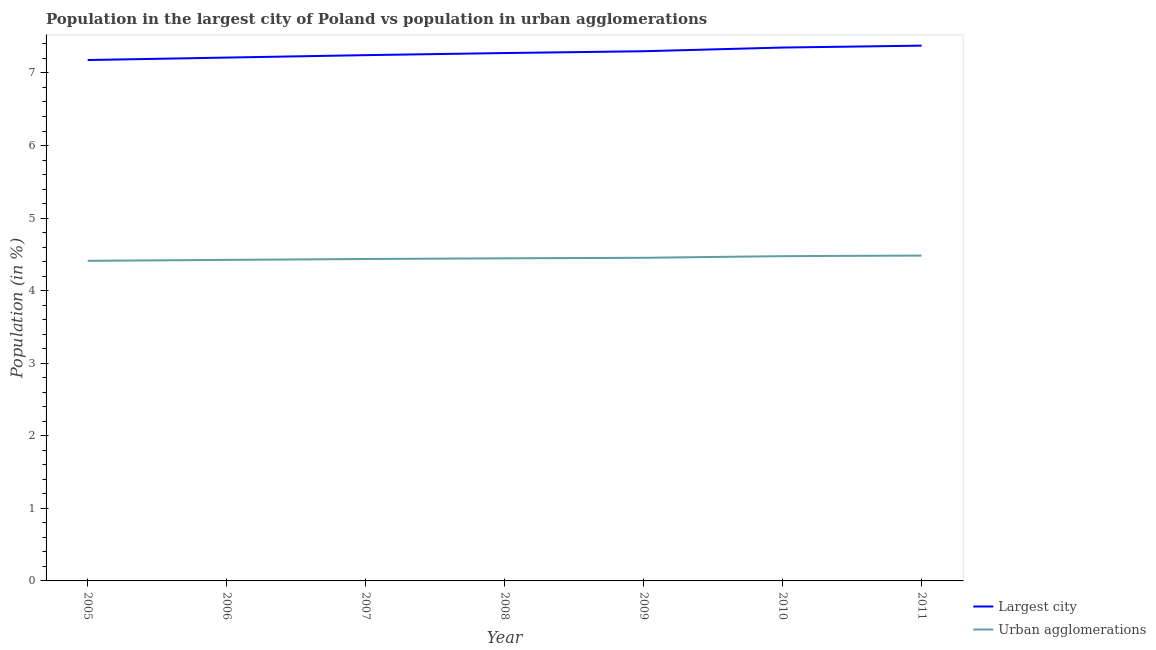What is the population in the largest city in 2009?
Provide a short and direct response. 7.3. Across all years, what is the maximum population in urban agglomerations?
Ensure brevity in your answer.  4.48. Across all years, what is the minimum population in the largest city?
Offer a terse response. 7.18. What is the total population in the largest city in the graph?
Provide a short and direct response. 50.94. What is the difference between the population in the largest city in 2006 and that in 2009?
Provide a short and direct response. -0.09. What is the difference between the population in urban agglomerations in 2007 and the population in the largest city in 2005?
Ensure brevity in your answer.  -2.74. What is the average population in urban agglomerations per year?
Keep it short and to the point. 4.45. In the year 2009, what is the difference between the population in the largest city and population in urban agglomerations?
Your answer should be very brief. 2.85. In how many years, is the population in urban agglomerations greater than 5.6 %?
Provide a short and direct response. 0. What is the ratio of the population in the largest city in 2007 to that in 2009?
Offer a terse response. 0.99. What is the difference between the highest and the second highest population in the largest city?
Your answer should be very brief. 0.03. What is the difference between the highest and the lowest population in the largest city?
Provide a short and direct response. 0.2. In how many years, is the population in the largest city greater than the average population in the largest city taken over all years?
Give a very brief answer. 3. Is the sum of the population in the largest city in 2009 and 2011 greater than the maximum population in urban agglomerations across all years?
Provide a succinct answer. Yes. Does the population in urban agglomerations monotonically increase over the years?
Ensure brevity in your answer.  Yes. How many lines are there?
Offer a terse response. 2. How many years are there in the graph?
Ensure brevity in your answer.  7. Are the values on the major ticks of Y-axis written in scientific E-notation?
Offer a very short reply. No. Does the graph contain any zero values?
Ensure brevity in your answer.  No. Where does the legend appear in the graph?
Your response must be concise. Bottom right. How are the legend labels stacked?
Offer a terse response. Vertical. What is the title of the graph?
Provide a succinct answer. Population in the largest city of Poland vs population in urban agglomerations. What is the label or title of the X-axis?
Ensure brevity in your answer.  Year. What is the Population (in %) in Largest city in 2005?
Ensure brevity in your answer.  7.18. What is the Population (in %) in Urban agglomerations in 2005?
Ensure brevity in your answer.  4.41. What is the Population (in %) of Largest city in 2006?
Your response must be concise. 7.21. What is the Population (in %) of Urban agglomerations in 2006?
Your answer should be compact. 4.42. What is the Population (in %) of Largest city in 2007?
Your response must be concise. 7.25. What is the Population (in %) of Urban agglomerations in 2007?
Provide a short and direct response. 4.44. What is the Population (in %) of Largest city in 2008?
Your answer should be very brief. 7.27. What is the Population (in %) in Urban agglomerations in 2008?
Make the answer very short. 4.45. What is the Population (in %) of Largest city in 2009?
Offer a terse response. 7.3. What is the Population (in %) of Urban agglomerations in 2009?
Your answer should be compact. 4.45. What is the Population (in %) of Largest city in 2010?
Your response must be concise. 7.35. What is the Population (in %) in Urban agglomerations in 2010?
Offer a terse response. 4.48. What is the Population (in %) of Largest city in 2011?
Keep it short and to the point. 7.38. What is the Population (in %) of Urban agglomerations in 2011?
Provide a succinct answer. 4.48. Across all years, what is the maximum Population (in %) in Largest city?
Your answer should be compact. 7.38. Across all years, what is the maximum Population (in %) in Urban agglomerations?
Your answer should be very brief. 4.48. Across all years, what is the minimum Population (in %) in Largest city?
Give a very brief answer. 7.18. Across all years, what is the minimum Population (in %) in Urban agglomerations?
Make the answer very short. 4.41. What is the total Population (in %) of Largest city in the graph?
Offer a terse response. 50.94. What is the total Population (in %) of Urban agglomerations in the graph?
Keep it short and to the point. 31.13. What is the difference between the Population (in %) in Largest city in 2005 and that in 2006?
Ensure brevity in your answer.  -0.03. What is the difference between the Population (in %) of Urban agglomerations in 2005 and that in 2006?
Provide a succinct answer. -0.01. What is the difference between the Population (in %) of Largest city in 2005 and that in 2007?
Your answer should be compact. -0.07. What is the difference between the Population (in %) in Urban agglomerations in 2005 and that in 2007?
Ensure brevity in your answer.  -0.03. What is the difference between the Population (in %) in Largest city in 2005 and that in 2008?
Offer a terse response. -0.1. What is the difference between the Population (in %) of Urban agglomerations in 2005 and that in 2008?
Your answer should be compact. -0.03. What is the difference between the Population (in %) of Largest city in 2005 and that in 2009?
Give a very brief answer. -0.12. What is the difference between the Population (in %) in Urban agglomerations in 2005 and that in 2009?
Offer a terse response. -0.04. What is the difference between the Population (in %) of Largest city in 2005 and that in 2010?
Provide a short and direct response. -0.17. What is the difference between the Population (in %) of Urban agglomerations in 2005 and that in 2010?
Give a very brief answer. -0.06. What is the difference between the Population (in %) in Largest city in 2005 and that in 2011?
Offer a terse response. -0.2. What is the difference between the Population (in %) in Urban agglomerations in 2005 and that in 2011?
Your answer should be very brief. -0.07. What is the difference between the Population (in %) of Largest city in 2006 and that in 2007?
Your answer should be very brief. -0.03. What is the difference between the Population (in %) of Urban agglomerations in 2006 and that in 2007?
Offer a very short reply. -0.01. What is the difference between the Population (in %) in Largest city in 2006 and that in 2008?
Offer a terse response. -0.06. What is the difference between the Population (in %) of Urban agglomerations in 2006 and that in 2008?
Your answer should be compact. -0.02. What is the difference between the Population (in %) in Largest city in 2006 and that in 2009?
Offer a very short reply. -0.09. What is the difference between the Population (in %) in Urban agglomerations in 2006 and that in 2009?
Your response must be concise. -0.03. What is the difference between the Population (in %) in Largest city in 2006 and that in 2010?
Offer a very short reply. -0.14. What is the difference between the Population (in %) in Urban agglomerations in 2006 and that in 2010?
Provide a short and direct response. -0.05. What is the difference between the Population (in %) of Largest city in 2006 and that in 2011?
Keep it short and to the point. -0.16. What is the difference between the Population (in %) in Urban agglomerations in 2006 and that in 2011?
Your answer should be compact. -0.06. What is the difference between the Population (in %) of Largest city in 2007 and that in 2008?
Keep it short and to the point. -0.03. What is the difference between the Population (in %) of Urban agglomerations in 2007 and that in 2008?
Make the answer very short. -0.01. What is the difference between the Population (in %) in Largest city in 2007 and that in 2009?
Make the answer very short. -0.05. What is the difference between the Population (in %) of Urban agglomerations in 2007 and that in 2009?
Provide a succinct answer. -0.02. What is the difference between the Population (in %) in Largest city in 2007 and that in 2010?
Offer a very short reply. -0.1. What is the difference between the Population (in %) of Urban agglomerations in 2007 and that in 2010?
Your answer should be very brief. -0.04. What is the difference between the Population (in %) of Largest city in 2007 and that in 2011?
Give a very brief answer. -0.13. What is the difference between the Population (in %) of Urban agglomerations in 2007 and that in 2011?
Offer a very short reply. -0.05. What is the difference between the Population (in %) in Largest city in 2008 and that in 2009?
Provide a succinct answer. -0.02. What is the difference between the Population (in %) in Urban agglomerations in 2008 and that in 2009?
Your answer should be very brief. -0.01. What is the difference between the Population (in %) in Largest city in 2008 and that in 2010?
Give a very brief answer. -0.08. What is the difference between the Population (in %) of Urban agglomerations in 2008 and that in 2010?
Your response must be concise. -0.03. What is the difference between the Population (in %) in Largest city in 2008 and that in 2011?
Keep it short and to the point. -0.1. What is the difference between the Population (in %) of Urban agglomerations in 2008 and that in 2011?
Your answer should be compact. -0.04. What is the difference between the Population (in %) in Largest city in 2009 and that in 2010?
Provide a succinct answer. -0.05. What is the difference between the Population (in %) of Urban agglomerations in 2009 and that in 2010?
Give a very brief answer. -0.02. What is the difference between the Population (in %) in Largest city in 2009 and that in 2011?
Provide a succinct answer. -0.08. What is the difference between the Population (in %) in Urban agglomerations in 2009 and that in 2011?
Keep it short and to the point. -0.03. What is the difference between the Population (in %) in Largest city in 2010 and that in 2011?
Provide a short and direct response. -0.03. What is the difference between the Population (in %) of Urban agglomerations in 2010 and that in 2011?
Your response must be concise. -0.01. What is the difference between the Population (in %) in Largest city in 2005 and the Population (in %) in Urban agglomerations in 2006?
Make the answer very short. 2.75. What is the difference between the Population (in %) of Largest city in 2005 and the Population (in %) of Urban agglomerations in 2007?
Your answer should be compact. 2.74. What is the difference between the Population (in %) of Largest city in 2005 and the Population (in %) of Urban agglomerations in 2008?
Offer a very short reply. 2.73. What is the difference between the Population (in %) in Largest city in 2005 and the Population (in %) in Urban agglomerations in 2009?
Provide a succinct answer. 2.73. What is the difference between the Population (in %) in Largest city in 2005 and the Population (in %) in Urban agglomerations in 2010?
Your answer should be very brief. 2.7. What is the difference between the Population (in %) of Largest city in 2005 and the Population (in %) of Urban agglomerations in 2011?
Give a very brief answer. 2.69. What is the difference between the Population (in %) in Largest city in 2006 and the Population (in %) in Urban agglomerations in 2007?
Offer a terse response. 2.78. What is the difference between the Population (in %) in Largest city in 2006 and the Population (in %) in Urban agglomerations in 2008?
Offer a very short reply. 2.77. What is the difference between the Population (in %) of Largest city in 2006 and the Population (in %) of Urban agglomerations in 2009?
Make the answer very short. 2.76. What is the difference between the Population (in %) of Largest city in 2006 and the Population (in %) of Urban agglomerations in 2010?
Provide a short and direct response. 2.74. What is the difference between the Population (in %) of Largest city in 2006 and the Population (in %) of Urban agglomerations in 2011?
Your response must be concise. 2.73. What is the difference between the Population (in %) in Largest city in 2007 and the Population (in %) in Urban agglomerations in 2008?
Keep it short and to the point. 2.8. What is the difference between the Population (in %) of Largest city in 2007 and the Population (in %) of Urban agglomerations in 2009?
Provide a succinct answer. 2.79. What is the difference between the Population (in %) in Largest city in 2007 and the Population (in %) in Urban agglomerations in 2010?
Keep it short and to the point. 2.77. What is the difference between the Population (in %) of Largest city in 2007 and the Population (in %) of Urban agglomerations in 2011?
Give a very brief answer. 2.76. What is the difference between the Population (in %) in Largest city in 2008 and the Population (in %) in Urban agglomerations in 2009?
Provide a succinct answer. 2.82. What is the difference between the Population (in %) in Largest city in 2008 and the Population (in %) in Urban agglomerations in 2010?
Your answer should be very brief. 2.8. What is the difference between the Population (in %) of Largest city in 2008 and the Population (in %) of Urban agglomerations in 2011?
Your answer should be very brief. 2.79. What is the difference between the Population (in %) in Largest city in 2009 and the Population (in %) in Urban agglomerations in 2010?
Your response must be concise. 2.82. What is the difference between the Population (in %) of Largest city in 2009 and the Population (in %) of Urban agglomerations in 2011?
Ensure brevity in your answer.  2.82. What is the difference between the Population (in %) of Largest city in 2010 and the Population (in %) of Urban agglomerations in 2011?
Offer a very short reply. 2.87. What is the average Population (in %) in Largest city per year?
Your answer should be very brief. 7.28. What is the average Population (in %) in Urban agglomerations per year?
Offer a terse response. 4.45. In the year 2005, what is the difference between the Population (in %) of Largest city and Population (in %) of Urban agglomerations?
Provide a short and direct response. 2.77. In the year 2006, what is the difference between the Population (in %) in Largest city and Population (in %) in Urban agglomerations?
Offer a terse response. 2.79. In the year 2007, what is the difference between the Population (in %) of Largest city and Population (in %) of Urban agglomerations?
Keep it short and to the point. 2.81. In the year 2008, what is the difference between the Population (in %) of Largest city and Population (in %) of Urban agglomerations?
Make the answer very short. 2.83. In the year 2009, what is the difference between the Population (in %) of Largest city and Population (in %) of Urban agglomerations?
Provide a short and direct response. 2.85. In the year 2010, what is the difference between the Population (in %) of Largest city and Population (in %) of Urban agglomerations?
Your response must be concise. 2.87. In the year 2011, what is the difference between the Population (in %) of Largest city and Population (in %) of Urban agglomerations?
Ensure brevity in your answer.  2.89. What is the ratio of the Population (in %) of Largest city in 2005 to that in 2006?
Your response must be concise. 1. What is the ratio of the Population (in %) of Largest city in 2005 to that in 2007?
Offer a very short reply. 0.99. What is the ratio of the Population (in %) in Urban agglomerations in 2005 to that in 2007?
Your answer should be very brief. 0.99. What is the ratio of the Population (in %) of Urban agglomerations in 2005 to that in 2008?
Your answer should be compact. 0.99. What is the ratio of the Population (in %) of Largest city in 2005 to that in 2009?
Provide a short and direct response. 0.98. What is the ratio of the Population (in %) in Urban agglomerations in 2005 to that in 2009?
Your answer should be very brief. 0.99. What is the ratio of the Population (in %) of Largest city in 2005 to that in 2010?
Offer a very short reply. 0.98. What is the ratio of the Population (in %) in Urban agglomerations in 2005 to that in 2010?
Your response must be concise. 0.99. What is the ratio of the Population (in %) in Largest city in 2005 to that in 2011?
Give a very brief answer. 0.97. What is the ratio of the Population (in %) in Urban agglomerations in 2005 to that in 2011?
Make the answer very short. 0.98. What is the ratio of the Population (in %) in Urban agglomerations in 2006 to that in 2007?
Make the answer very short. 1. What is the ratio of the Population (in %) of Largest city in 2006 to that in 2010?
Your response must be concise. 0.98. What is the ratio of the Population (in %) of Urban agglomerations in 2006 to that in 2010?
Offer a very short reply. 0.99. What is the ratio of the Population (in %) in Largest city in 2006 to that in 2011?
Ensure brevity in your answer.  0.98. What is the ratio of the Population (in %) of Urban agglomerations in 2006 to that in 2011?
Provide a succinct answer. 0.99. What is the ratio of the Population (in %) in Largest city in 2007 to that in 2009?
Offer a very short reply. 0.99. What is the ratio of the Population (in %) in Largest city in 2007 to that in 2010?
Your response must be concise. 0.99. What is the ratio of the Population (in %) in Largest city in 2007 to that in 2011?
Make the answer very short. 0.98. What is the ratio of the Population (in %) of Urban agglomerations in 2007 to that in 2011?
Offer a terse response. 0.99. What is the ratio of the Population (in %) in Largest city in 2008 to that in 2010?
Offer a very short reply. 0.99. What is the ratio of the Population (in %) in Largest city in 2008 to that in 2011?
Make the answer very short. 0.99. What is the ratio of the Population (in %) in Largest city in 2009 to that in 2010?
Provide a succinct answer. 0.99. What is the ratio of the Population (in %) of Urban agglomerations in 2009 to that in 2010?
Ensure brevity in your answer.  0.99. What is the ratio of the Population (in %) of Urban agglomerations in 2009 to that in 2011?
Make the answer very short. 0.99. What is the ratio of the Population (in %) of Urban agglomerations in 2010 to that in 2011?
Keep it short and to the point. 1. What is the difference between the highest and the second highest Population (in %) of Largest city?
Keep it short and to the point. 0.03. What is the difference between the highest and the second highest Population (in %) in Urban agglomerations?
Your answer should be compact. 0.01. What is the difference between the highest and the lowest Population (in %) of Largest city?
Give a very brief answer. 0.2. What is the difference between the highest and the lowest Population (in %) of Urban agglomerations?
Your answer should be compact. 0.07. 